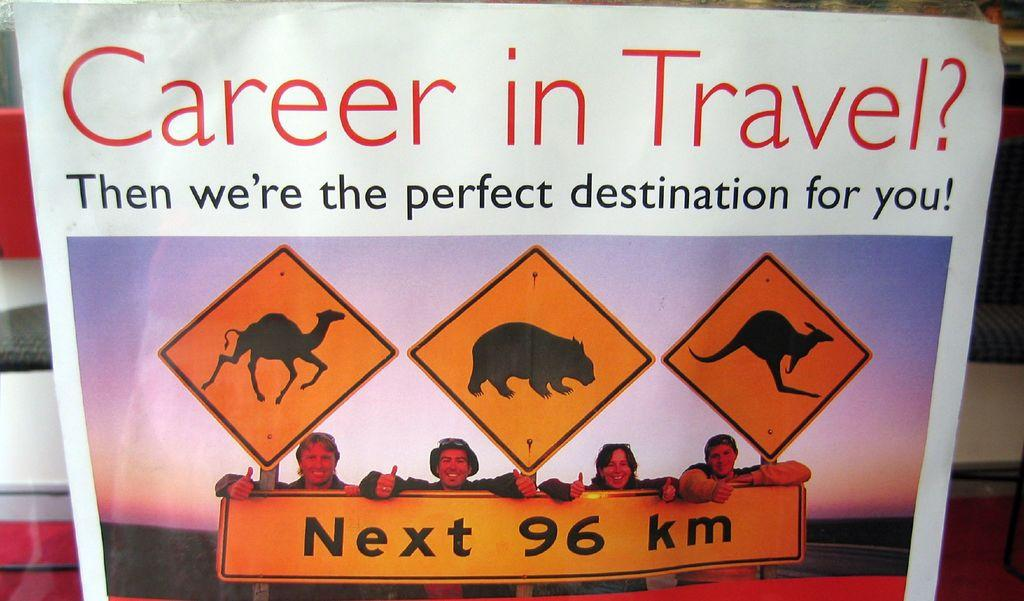<image>
Give a short and clear explanation of the subsequent image. A poster that has images of road signs with animals on them insinuating that if you want a job traveling, then they are in the best location for you. 